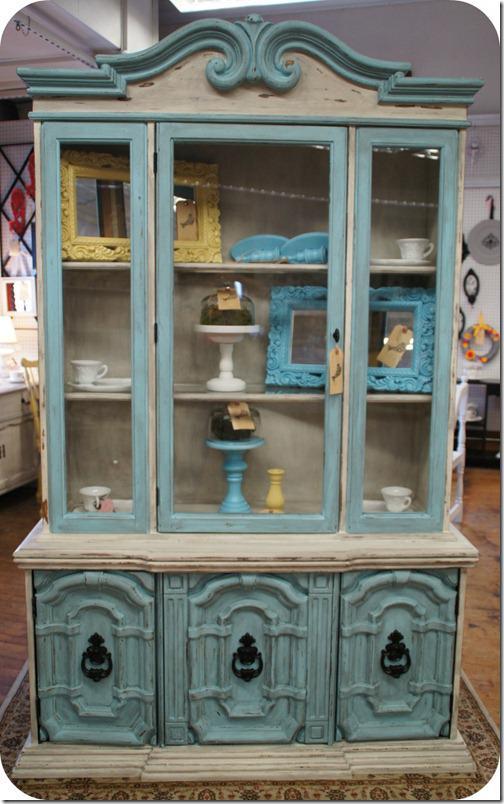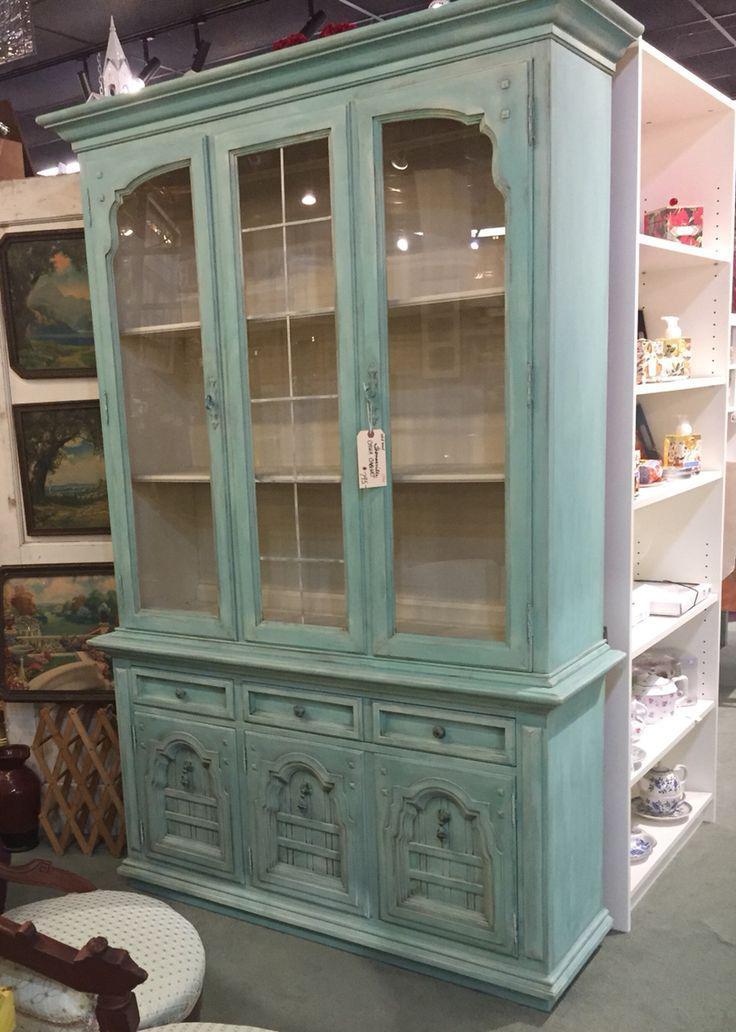The first image is the image on the left, the second image is the image on the right. Examine the images to the left and right. Is the description "The teal cabinet has exactly three lower drawers." accurate? Answer yes or no. Yes. The first image is the image on the left, the second image is the image on the right. Analyze the images presented: Is the assertion "AN image shows a flat-topped cabinet above a three stacked drawer section that is not flat." valid? Answer yes or no. No. 